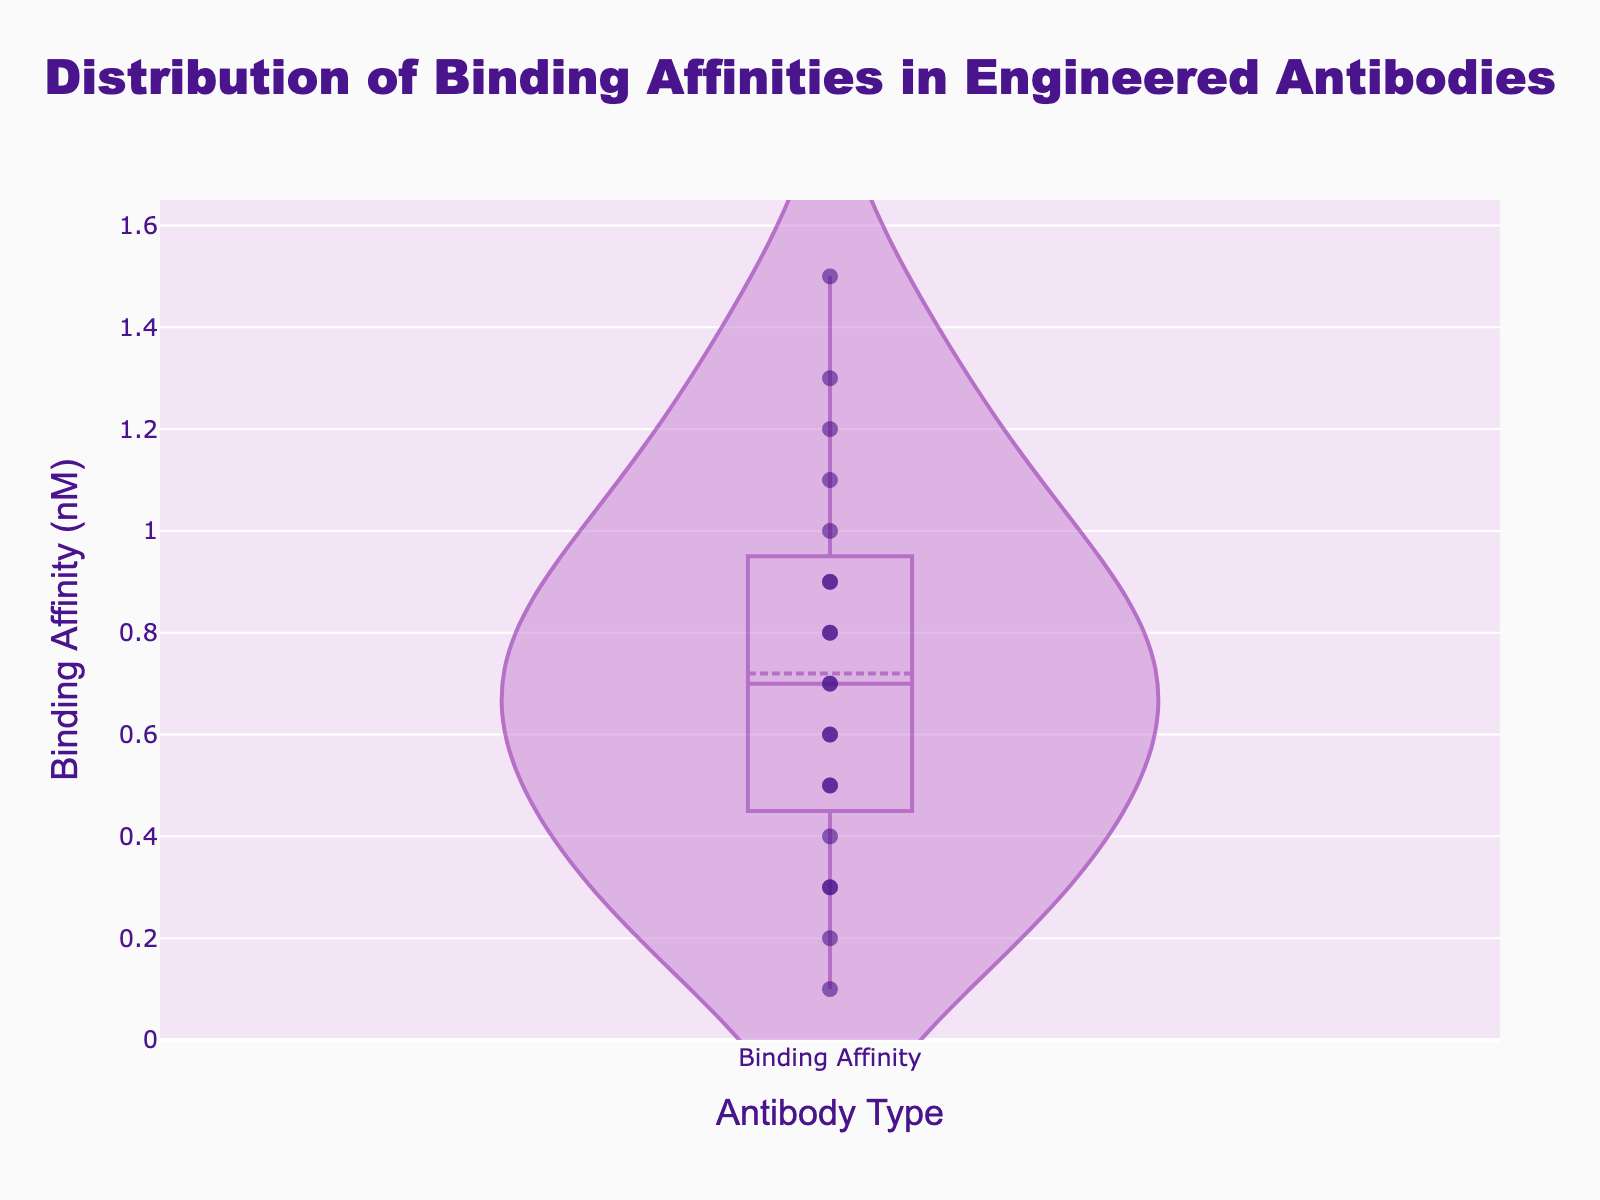what is the title of the plot? The title is located at the top of the plot and is centered, indicating what the plot is about. In this instance, it reads "Distribution of Binding Affinities in Engineered Antibodies".
Answer: Distribution of Binding Affinities in Engineered Antibodies What is the range of the y-axis? The y-axis represents the binding affinity in nanomolar (nM). From examining the ticks on the y-axis, it ranges from 0 to approximately 1.5 nanomolar.
Answer: 0 to 1.5 nM How many data points are shown in the plot? There are 20 engineered antibodies listed in the dataset, each corresponding to its binding affinity. By counting the data points (markers) plotted on the figure, one can see there are 20.
Answer: 20 What is the median binding affinity from the visual representation? The median can be inferred from the density plot's mean and distribution. As the binding affinities seem symmetrically distributed around the central value of approximately 0.7-0.8 nM, there is an even spread on both sides. Hence, the median is around the middle of the distribution.
Answer: Approximately 0.7-0.8 nM What is the interquartile range (IQR) of the binding affinities? The IQR is the range between the 25th and 75th percentiles. These percentiles can be estimated visually from the violin plot where the box extends. Assuming the 25th percentile is around 0.5 nM and the 75th percentile is around 1.1 nM, the IQR = 1.1 - 0.5.
Answer: Approximately 0.6 nM Which antibody has the lowest binding affinity? By looking at the bottom-most data point on the figure, Trastuzumab has the lowest binding affinity value at 0.1 nM.
Answer: Trastuzumab How does the mean binding affinity compare to the median? From the violin plot, the mean binding affinity is visually indicated by a line. Comparing the mean line's position to the median value around the central distribution, the mean appears slightly higher than the median.
Answer: Mean > Median Which antibody has a binding affinity closest to 1 nM? By inspecting data points near 1 nM, Palivizumab has a binding affinity closest to 1 nM.
Answer: Palivizumab How does the binding affinity for Tocilizumab compare with Cetuximab? From the figure, determine the position of each antibody on the y-axis. Tocilizumab has a binding affinity of 1.5 nM, and Cetuximab has a binding affinity of 0.2 nM; thus, Tocilizumab has a much higher binding affinity.
Answer: Tocilizumab > Cetuximab 